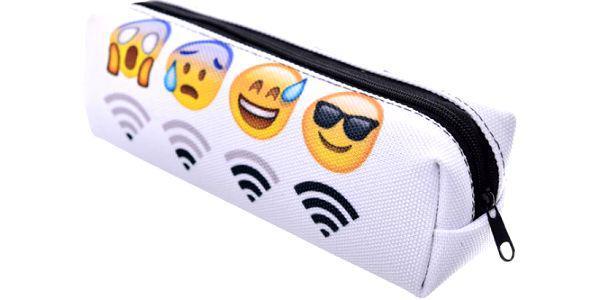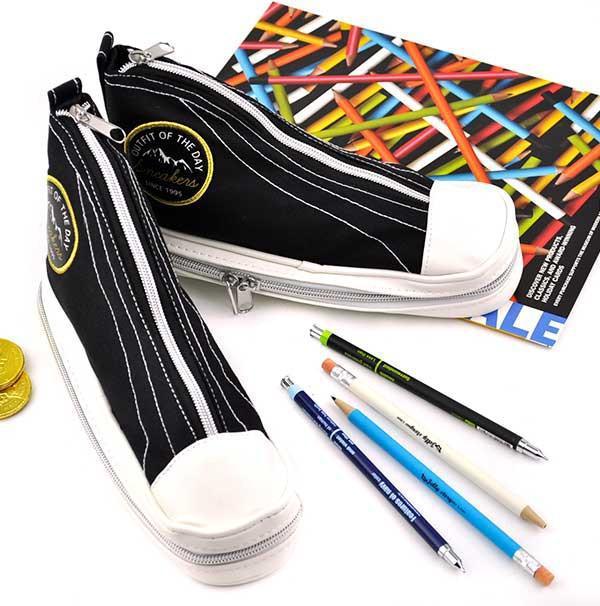The first image is the image on the left, the second image is the image on the right. For the images shown, is this caption "for the image on the right side, the bag has black and white zigzags." true? Answer yes or no. No. 